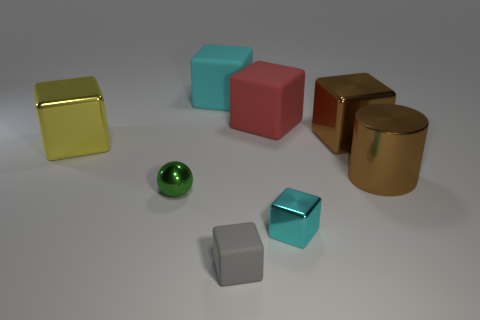Subtract all gray rubber cubes. How many cubes are left? 5 Subtract all yellow cubes. How many cubes are left? 5 Subtract all blue blocks. Subtract all red balls. How many blocks are left? 6 Add 2 brown things. How many objects exist? 10 Subtract all spheres. How many objects are left? 7 Add 1 tiny metallic spheres. How many tiny metallic spheres are left? 2 Add 3 large rubber cubes. How many large rubber cubes exist? 5 Subtract 0 green blocks. How many objects are left? 8 Subtract all large red rubber cubes. Subtract all metal cylinders. How many objects are left? 6 